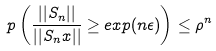Convert formula to latex. <formula><loc_0><loc_0><loc_500><loc_500>\ p \left ( \frac { | | S _ { n } | | } { | | S _ { n } x | | } \geq e x p ( n \epsilon ) \right ) \leq \rho ^ { n }</formula> 